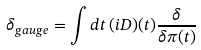<formula> <loc_0><loc_0><loc_500><loc_500>\delta _ { g a u g e } = \int d t \, ( i D ) ( t ) \frac { \delta } { \delta \pi ( t ) }</formula> 